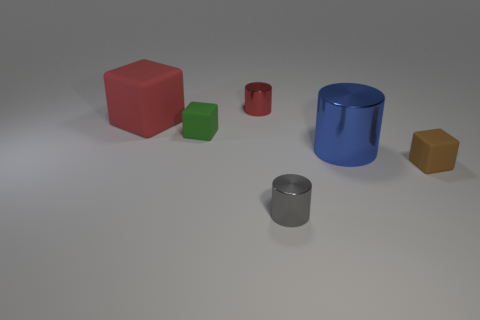Add 1 large green metallic objects. How many objects exist? 7 Subtract 0 blue blocks. How many objects are left? 6 Subtract all large purple metallic things. Subtract all gray metal objects. How many objects are left? 5 Add 6 shiny cylinders. How many shiny cylinders are left? 9 Add 2 tiny red cylinders. How many tiny red cylinders exist? 3 